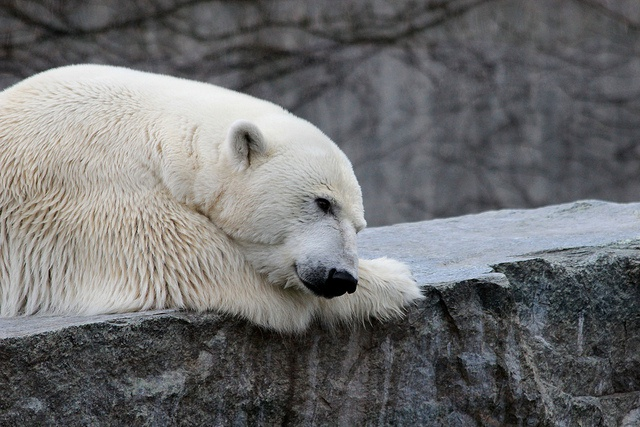Describe the objects in this image and their specific colors. I can see a bear in black, darkgray, lightgray, and gray tones in this image. 